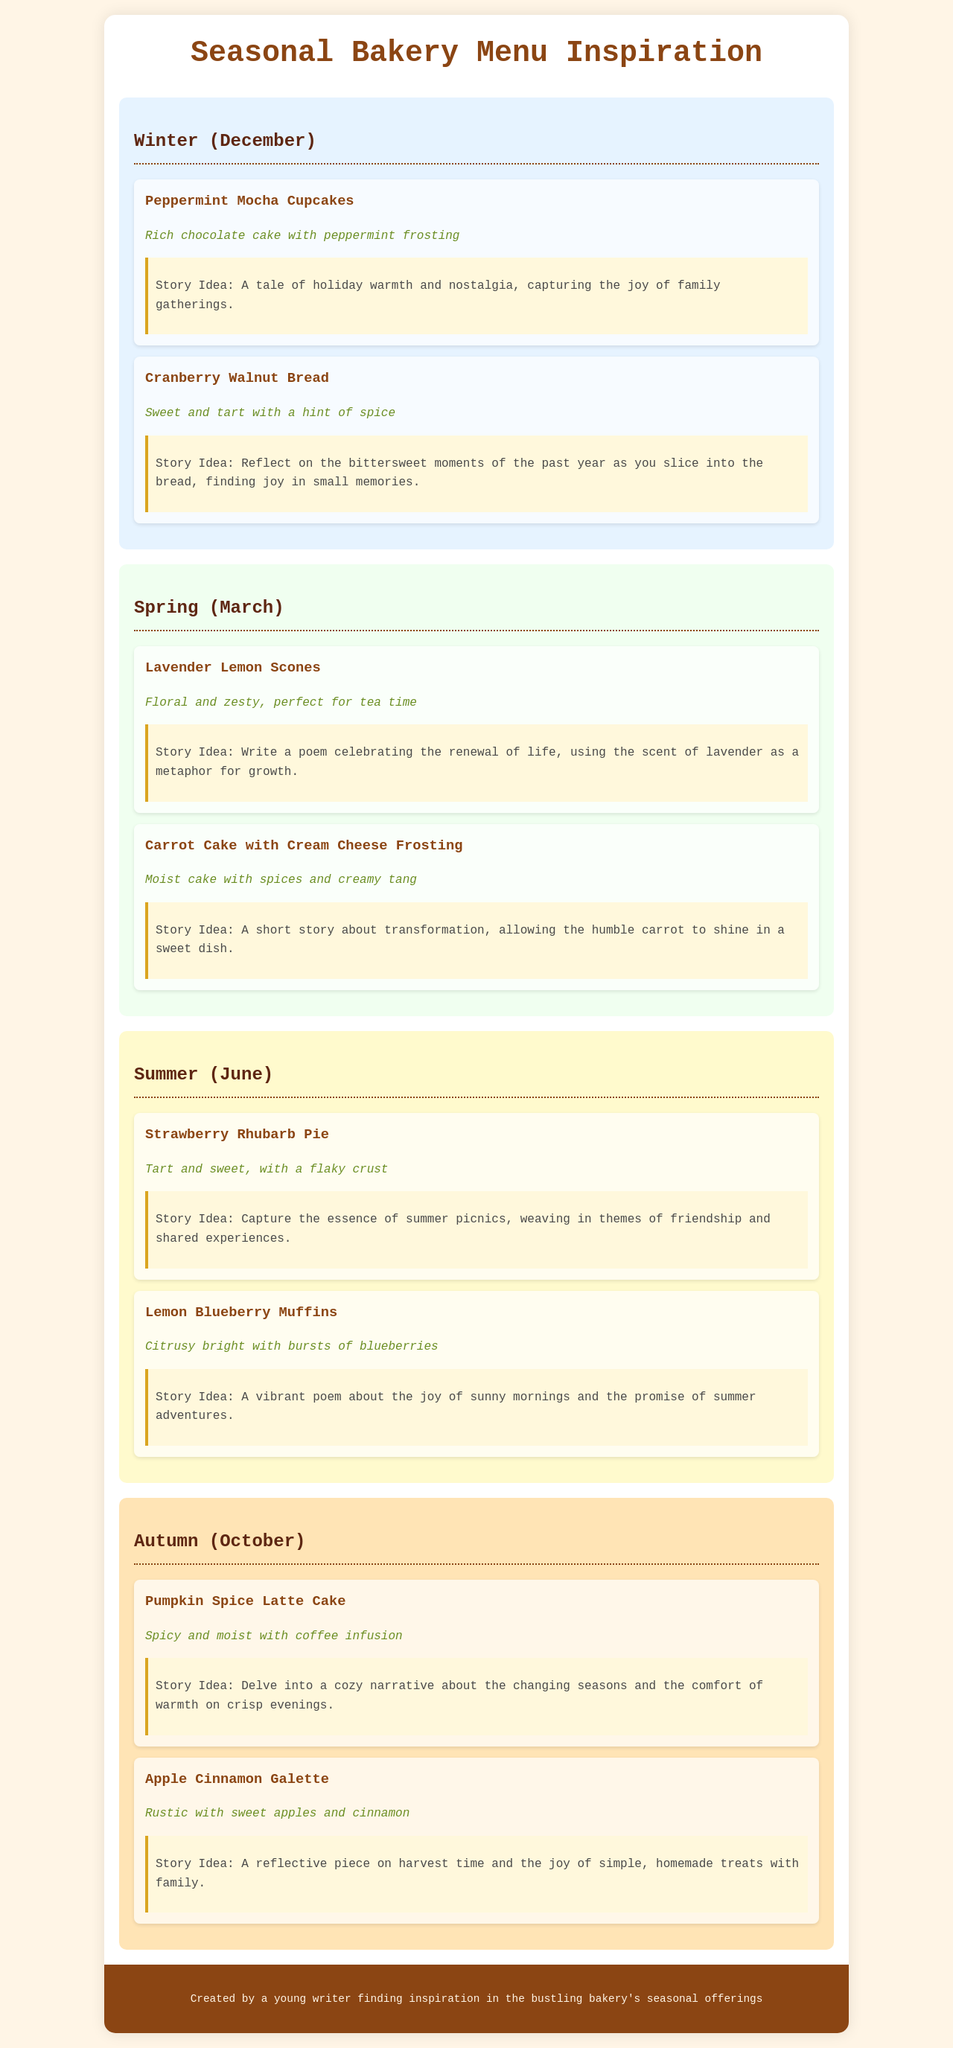What is the first item on the winter menu? The first item listed in the winter section is "Peppermint Mocha Cupcakes."
Answer: Peppermint Mocha Cupcakes What flavor is described for the Carrot Cake? The Carrot Cake is described as "Moist cake with spices and creamy tang."
Answer: Moist cake with spices and creamy tang What type of dessert is featured in the summer section? The summer section includes both "Strawberry Rhubarb Pie" and "Lemon Blueberry Muffins."
Answer: Strawberry Rhubarb Pie, Lemon Blueberry Muffins How many seasonal sections are there? There are four seasonal sections: winter, spring, summer, and autumn.
Answer: Four What is the story idea associated with the Apple Cinnamon Galette? The story idea is "A reflective piece on harvest time and the joy of simple, homemade treats with family."
Answer: A reflective piece on harvest time and the joy of simple, homemade treats with family What color background is used for the autumn section? The autumn section has a background color of "#FFE4B5."
Answer: #FFE4B5 Which seasonal item has a story idea about renewal of life? The item with a story idea about renewal of life is "Lavender Lemon Scones."
Answer: Lavender Lemon Scones How would you describe the flavor of the Pumpkin Spice Latte Cake? The flavor is described as "Spicy and moist with coffee infusion."
Answer: Spicy and moist with coffee infusion 